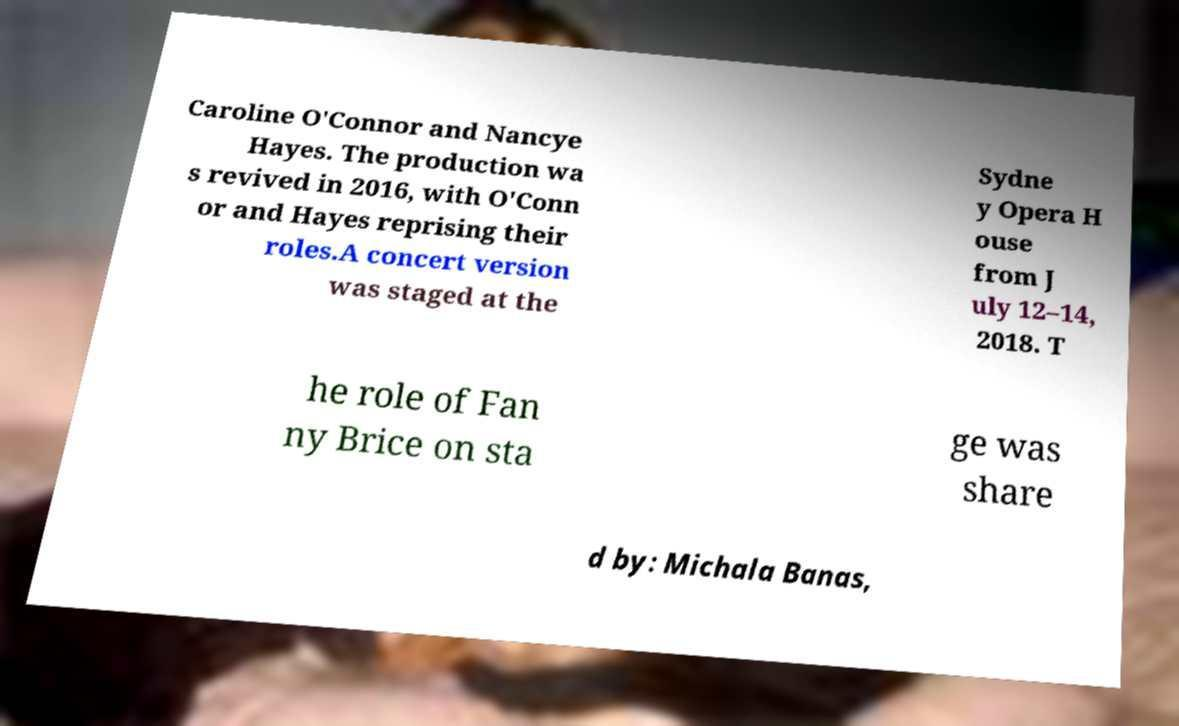Please identify and transcribe the text found in this image. Caroline O'Connor and Nancye Hayes. The production wa s revived in 2016, with O'Conn or and Hayes reprising their roles.A concert version was staged at the Sydne y Opera H ouse from J uly 12–14, 2018. T he role of Fan ny Brice on sta ge was share d by: Michala Banas, 